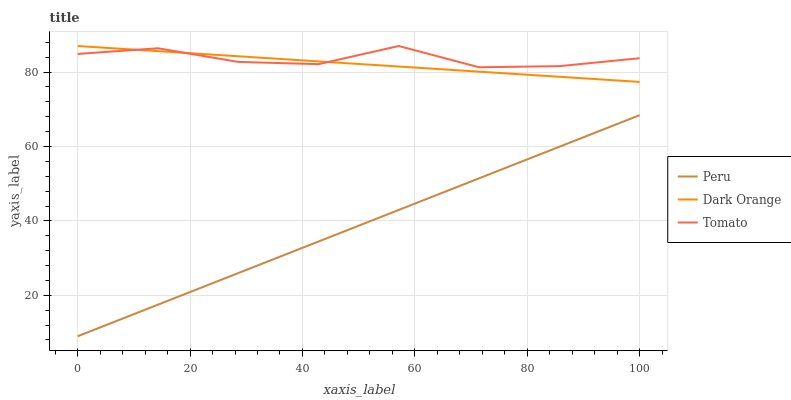Does Peru have the minimum area under the curve?
Answer yes or no. Yes. Does Tomato have the maximum area under the curve?
Answer yes or no. Yes. Does Dark Orange have the minimum area under the curve?
Answer yes or no. No. Does Dark Orange have the maximum area under the curve?
Answer yes or no. No. Is Peru the smoothest?
Answer yes or no. Yes. Is Tomato the roughest?
Answer yes or no. Yes. Is Dark Orange the smoothest?
Answer yes or no. No. Is Dark Orange the roughest?
Answer yes or no. No. Does Peru have the lowest value?
Answer yes or no. Yes. Does Dark Orange have the lowest value?
Answer yes or no. No. Does Dark Orange have the highest value?
Answer yes or no. Yes. Does Peru have the highest value?
Answer yes or no. No. Is Peru less than Tomato?
Answer yes or no. Yes. Is Dark Orange greater than Peru?
Answer yes or no. Yes. Does Tomato intersect Dark Orange?
Answer yes or no. Yes. Is Tomato less than Dark Orange?
Answer yes or no. No. Is Tomato greater than Dark Orange?
Answer yes or no. No. Does Peru intersect Tomato?
Answer yes or no. No. 